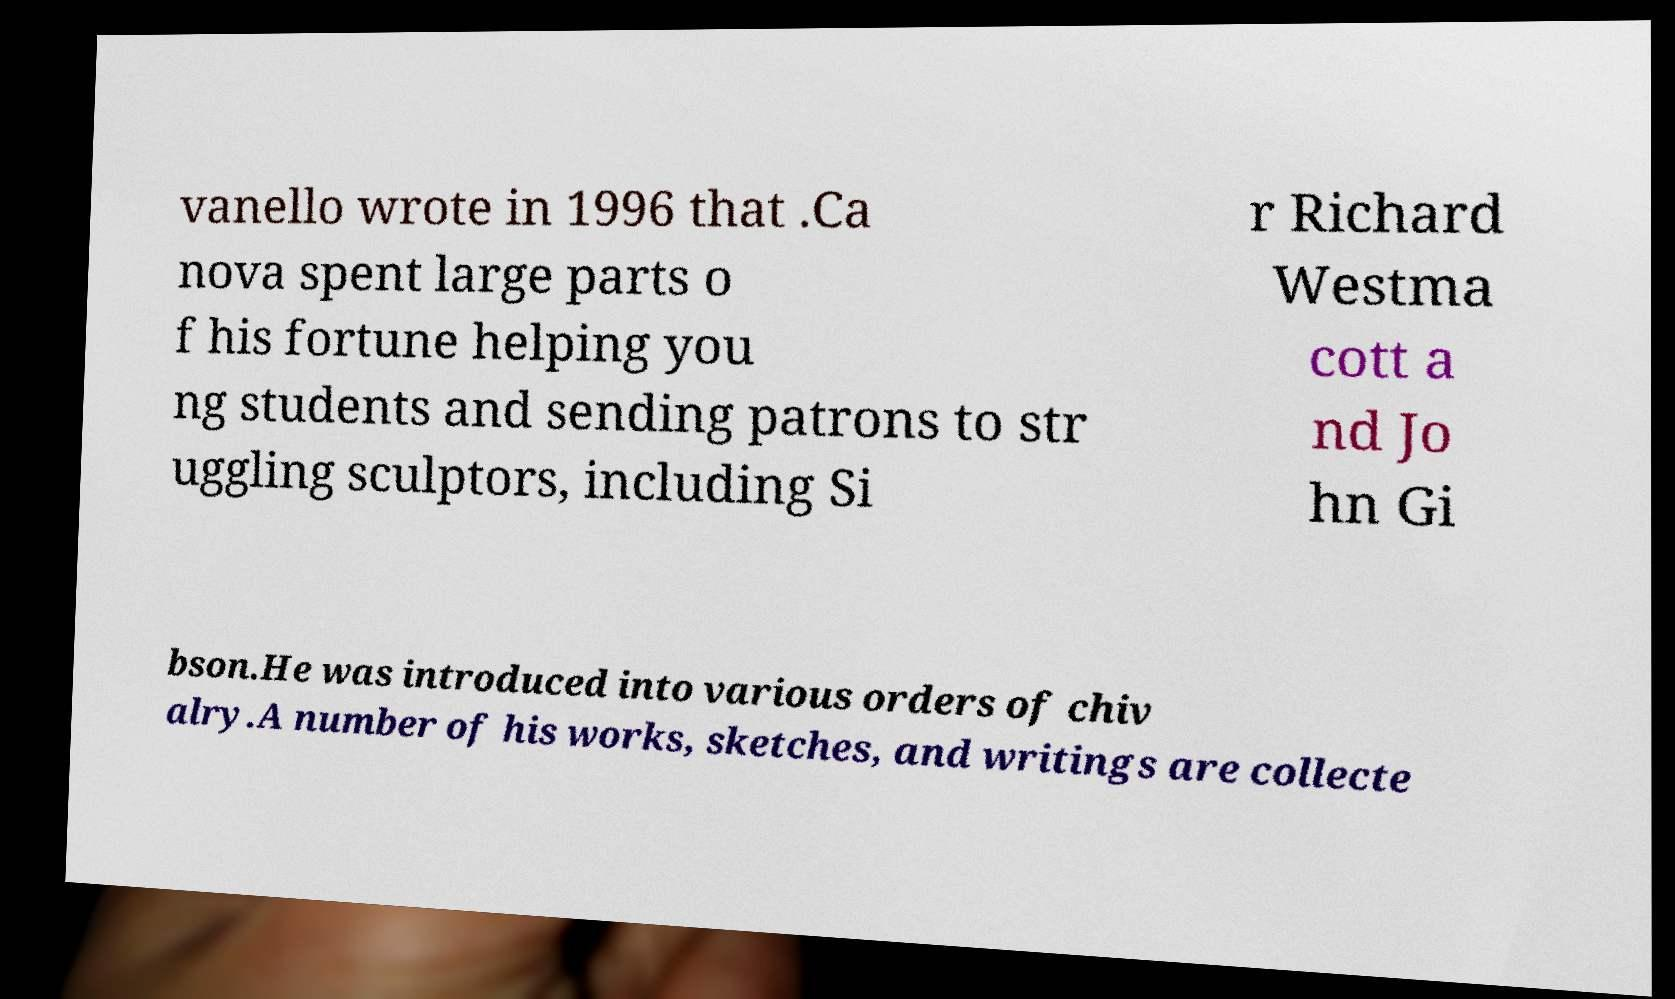Could you extract and type out the text from this image? vanello wrote in 1996 that .Ca nova spent large parts o f his fortune helping you ng students and sending patrons to str uggling sculptors, including Si r Richard Westma cott a nd Jo hn Gi bson.He was introduced into various orders of chiv alry.A number of his works, sketches, and writings are collecte 